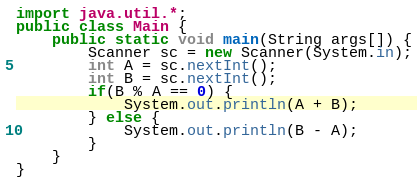Convert code to text. <code><loc_0><loc_0><loc_500><loc_500><_Java_>import java.util.*;
public class Main {
	public static void main(String args[]) {
		Scanner sc = new Scanner(System.in);
		int A = sc.nextInt();
		int B = sc.nextInt();
		if(B % A == 0) {
			System.out.println(A + B);
		} else {
			System.out.println(B - A);
		}
	}
}
</code> 